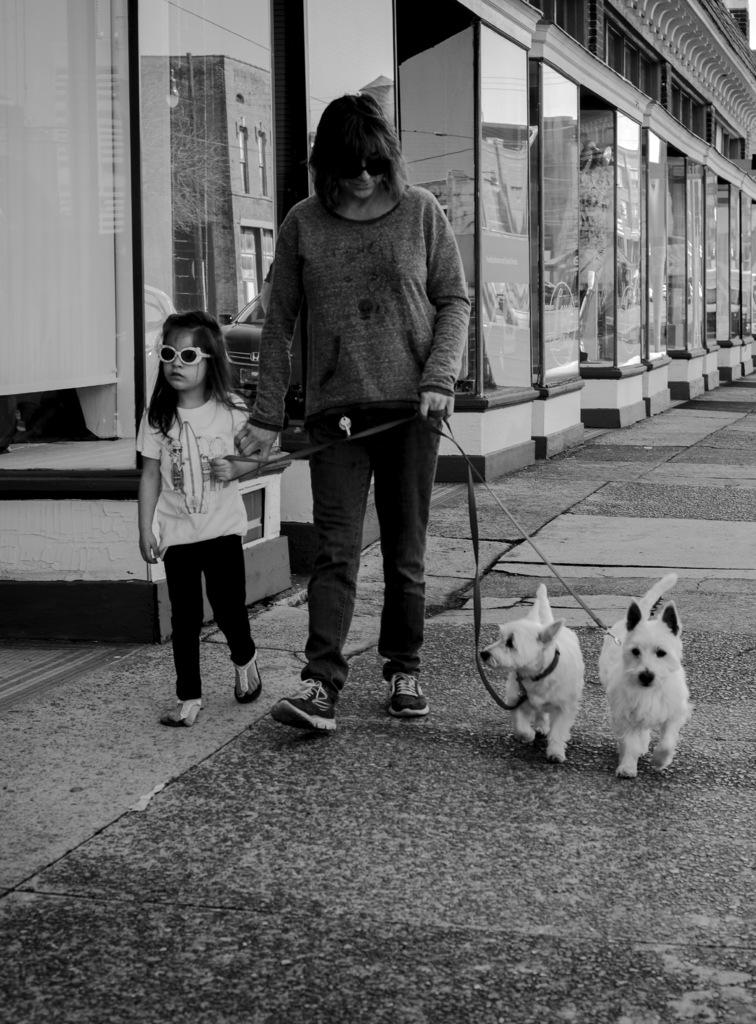Who is the main subject in the image? There is a woman in the image. What is the woman doing in the image? The woman is walking on a footpath. Who is accompanying the woman in the image? There is a girl on the woman's right side and two puppies on the woman's left side. What type of yoke can be seen in the image? There is no yoke present in the image. Can you tell me how many balls are being juggled by the woman in the image? There are no balls or juggling activity depicted in the image. 